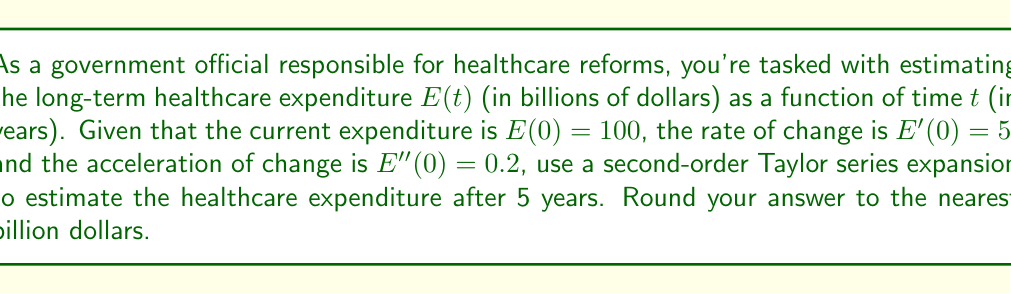Solve this math problem. To estimate the healthcare expenditure after 5 years using a second-order Taylor series expansion, we'll follow these steps:

1) The general form of a second-order Taylor series expansion around $t=0$ is:

   $$E(t) \approx E(0) + E'(0)t + \frac{E''(0)}{2!}t^2$$

2) We're given:
   $E(0) = 100$ (current expenditure)
   $E'(0) = 5$ (rate of change)
   $E''(0) = 0.2$ (acceleration of change)

3) Substituting these values into the Taylor series:

   $$E(t) \approx 100 + 5t + \frac{0.2}{2}t^2$$

4) Simplify:

   $$E(t) \approx 100 + 5t + 0.1t^2$$

5) We want to estimate the expenditure after 5 years, so let $t = 5$:

   $$E(5) \approx 100 + 5(5) + 0.1(5^2)$$

6) Calculate:

   $$E(5) \approx 100 + 25 + 0.1(25) = 100 + 25 + 2.5 = 127.5$$

7) Rounding to the nearest billion:

   $$E(5) \approx 128$$ billion dollars
Answer: $128 billion 